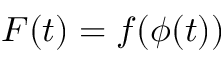<formula> <loc_0><loc_0><loc_500><loc_500>F ( t ) = f ( \phi ( t ) )</formula> 